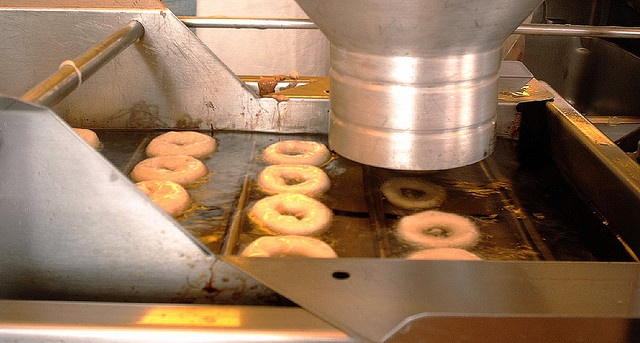Describe the objects in this image and their specific colors. I can see oven in gray, black, and maroon tones, donut in gray, khaki, orange, and olive tones, donut in gray, tan, olive, and maroon tones, donut in gray, orange, khaki, and olive tones, and donut in gray, maroon, black, and olive tones in this image. 